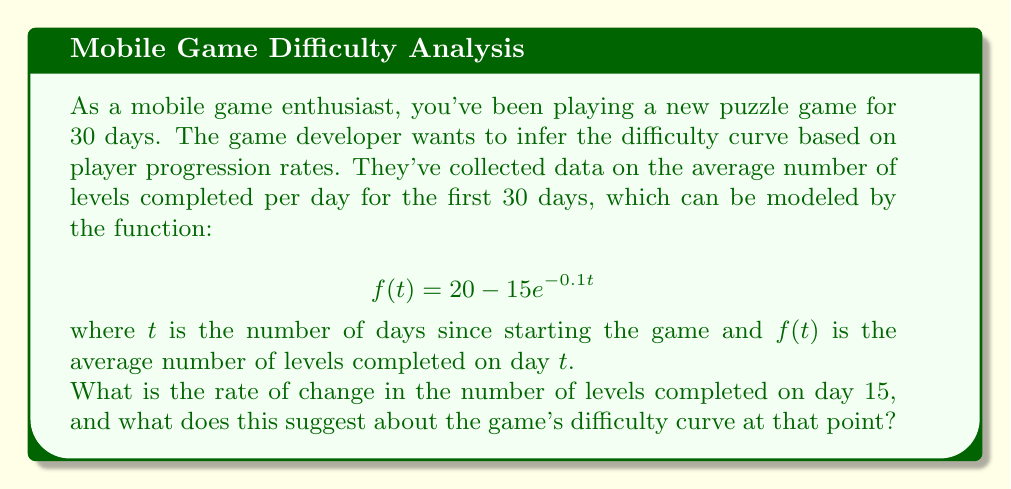Give your solution to this math problem. To solve this problem, we need to follow these steps:

1) The rate of change in the number of levels completed is given by the derivative of the function $f(t)$. Let's call this derivative $f'(t)$.

2) To find $f'(t)$, we use the chain rule:

   $$f'(t) = -15 \cdot (-0.1) \cdot e^{-0.1t} = 1.5e^{-0.1t}$$

3) Now, we need to evaluate $f'(15)$:

   $$f'(15) = 1.5e^{-0.1(15)} = 1.5e^{-1.5} \approx 0.334$$

4) Interpreting this result:
   - The rate of change is positive, meaning players are still improving and completing more levels each day.
   - However, the rate is relatively small (less than 1 level per day), suggesting that player improvement is slowing down.

5) What this suggests about the game's difficulty curve:
   - The game is still challenging enough that players are improving, but not so difficult that they're stuck.
   - The slowing rate of improvement suggests that the difficulty is well-balanced at this point, providing a good challenge without being overwhelming.
   - This gradual increase in difficulty is often considered ideal for maintaining player engagement in mobile games.
Answer: 0.334 levels/day; difficulty is well-balanced, providing sustained challenge 